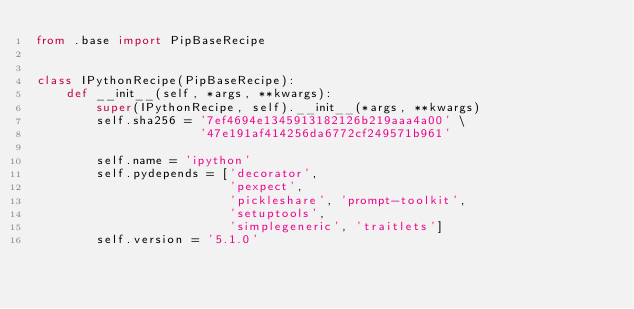Convert code to text. <code><loc_0><loc_0><loc_500><loc_500><_Python_>from .base import PipBaseRecipe


class IPythonRecipe(PipBaseRecipe):
    def __init__(self, *args, **kwargs):
        super(IPythonRecipe, self).__init__(*args, **kwargs)
        self.sha256 = '7ef4694e1345913182126b219aaa4a00' \
                      '47e191af414256da6772cf249571b961'

        self.name = 'ipython'
        self.pydepends = ['decorator',
                          'pexpect',
                          'pickleshare', 'prompt-toolkit',
                          'setuptools',
                          'simplegeneric', 'traitlets']
        self.version = '5.1.0'
</code> 